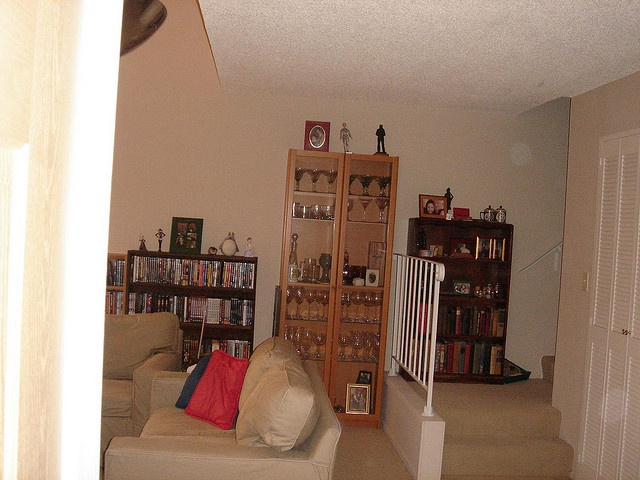Describe the objects in this image and their specific colors. I can see couch in beige, gray, tan, and brown tones, book in beige, black, maroon, and gray tones, couch in beige, brown, gray, and maroon tones, chair in beige, brown, gray, and maroon tones, and wine glass in beige, maroon, brown, and black tones in this image. 